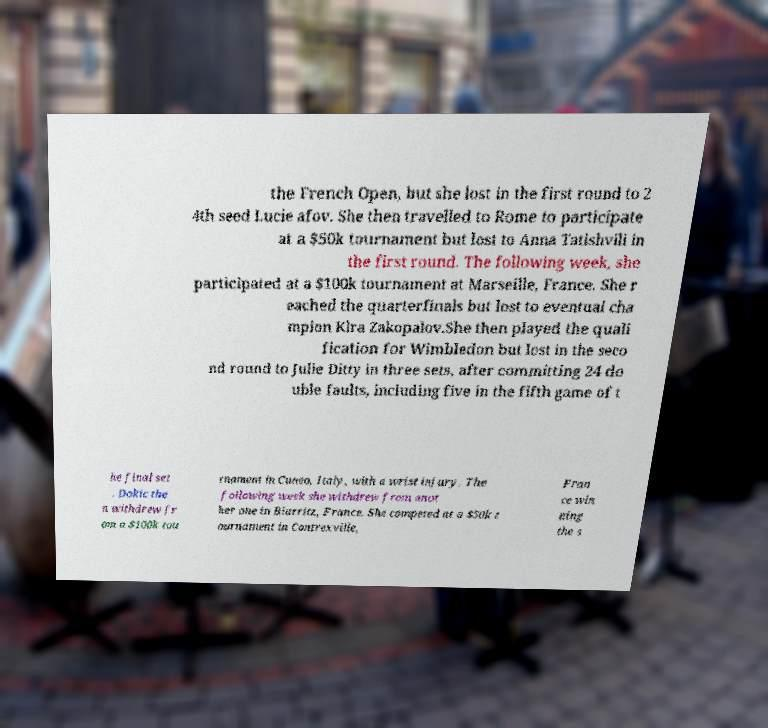I need the written content from this picture converted into text. Can you do that? the French Open, but she lost in the first round to 2 4th seed Lucie afov. She then travelled to Rome to participate at a $50k tournament but lost to Anna Tatishvili in the first round. The following week, she participated at a $100k tournament at Marseille, France. She r eached the quarterfinals but lost to eventual cha mpion Klra Zakopalov.She then played the quali fication for Wimbledon but lost in the seco nd round to Julie Ditty in three sets, after committing 24 do uble faults, including five in the fifth game of t he final set . Dokic the n withdrew fr om a $100k tou rnament in Cuneo, Italy, with a wrist injury. The following week she withdrew from anot her one in Biarritz, France. She competed at a $50k t ournament in Contrexville, Fran ce win ning the s 